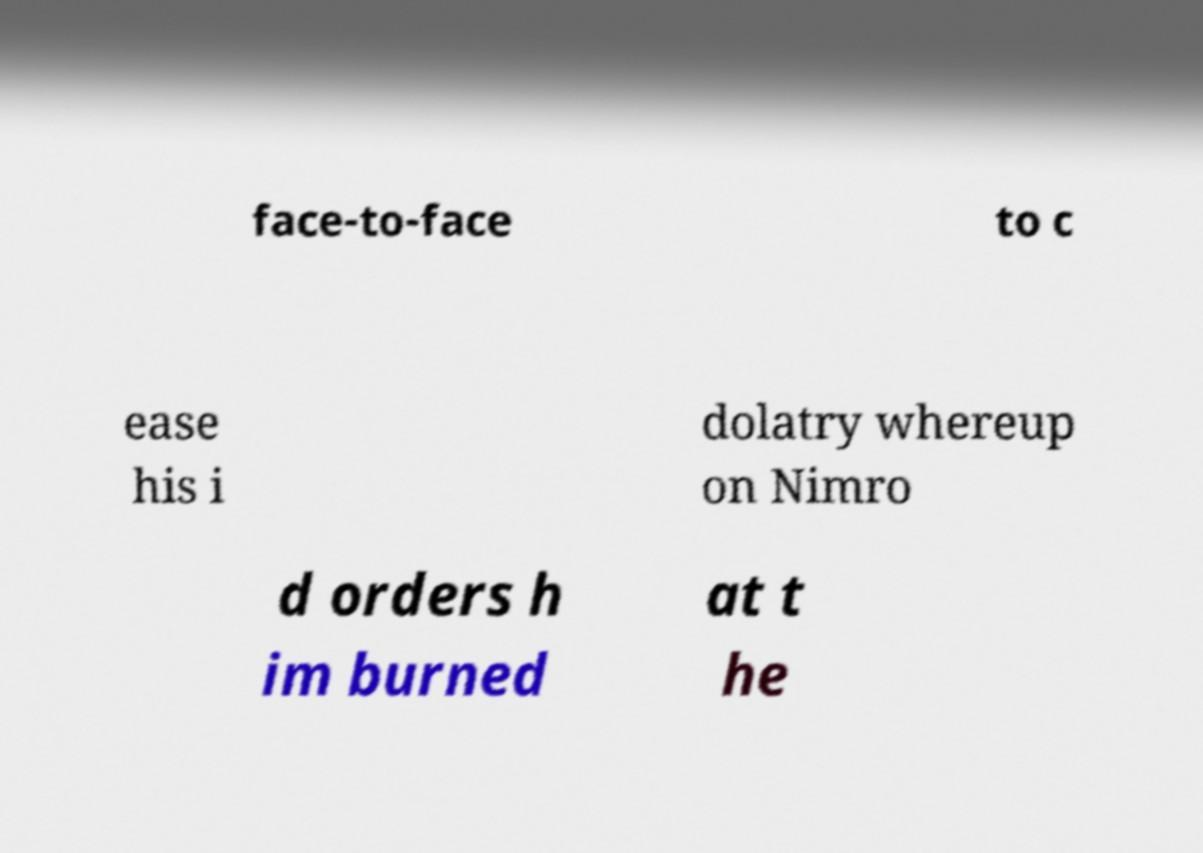Could you extract and type out the text from this image? face-to-face to c ease his i dolatry whereup on Nimro d orders h im burned at t he 